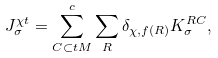Convert formula to latex. <formula><loc_0><loc_0><loc_500><loc_500>J _ { \sigma } ^ { \chi t } = \sum _ { C \subset t M } ^ { c } \sum _ { R } \delta _ { \chi , f ( R ) } K _ { \sigma } ^ { R C } ,</formula> 